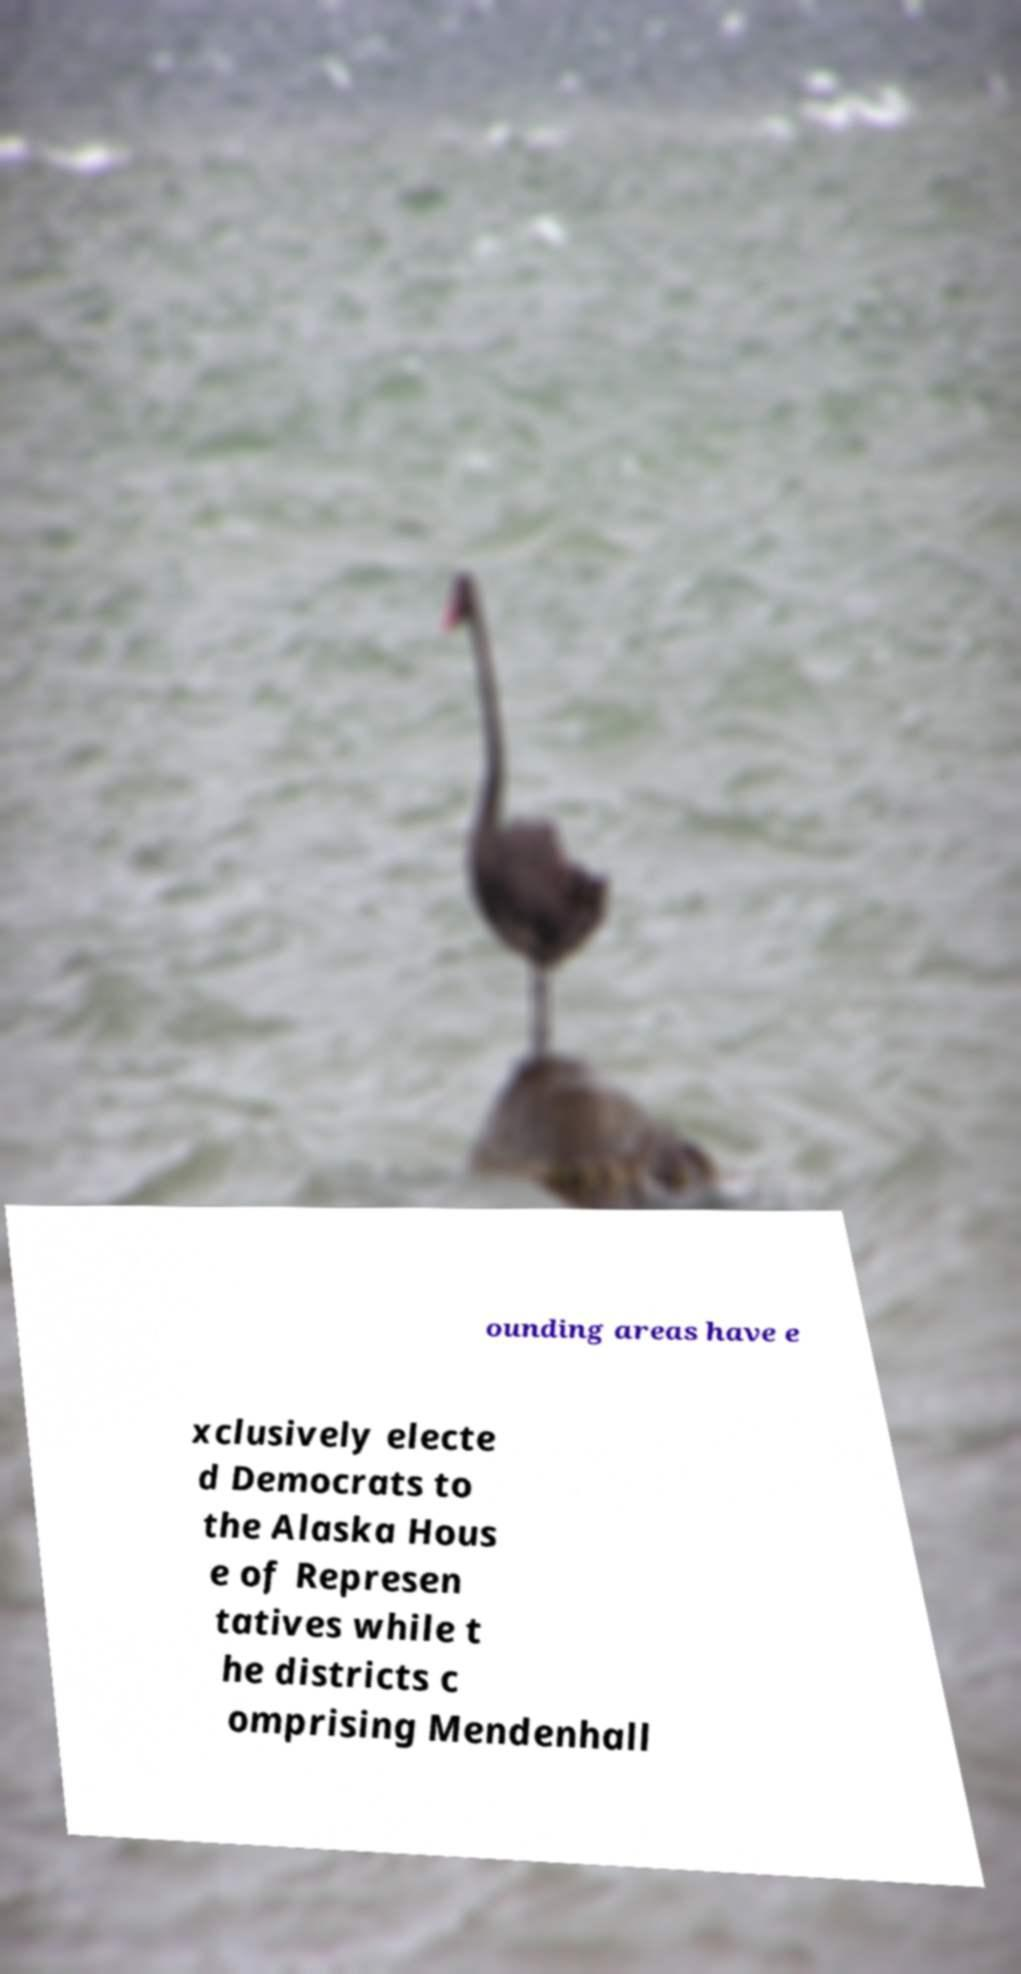For documentation purposes, I need the text within this image transcribed. Could you provide that? ounding areas have e xclusively electe d Democrats to the Alaska Hous e of Represen tatives while t he districts c omprising Mendenhall 